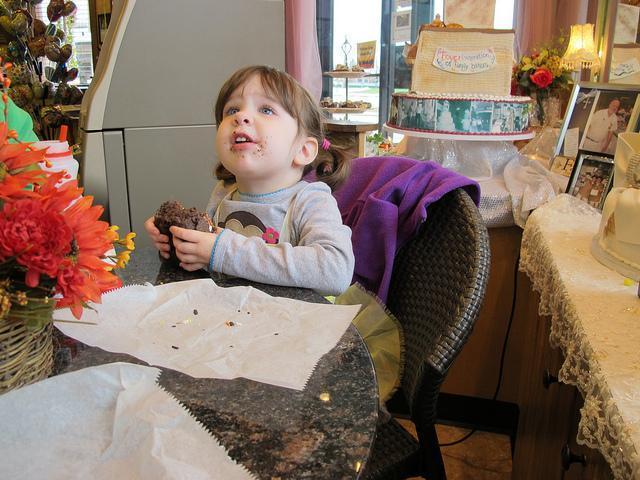Is the statement "The donut is away from the dining table." accurate regarding the image?
Answer yes or no. Yes. 